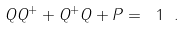<formula> <loc_0><loc_0><loc_500><loc_500>Q Q ^ { + } + Q ^ { + } Q + P = \ 1 \ .</formula> 